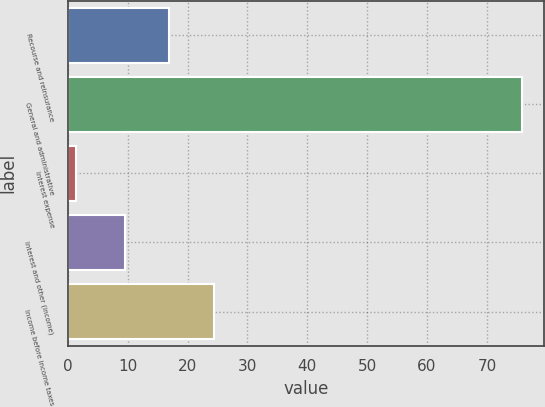Convert chart. <chart><loc_0><loc_0><loc_500><loc_500><bar_chart><fcel>Recourse and reinsurance<fcel>General and administrative<fcel>Interest expense<fcel>Interest and other (income)<fcel>Income before income taxes<nl><fcel>16.94<fcel>75.8<fcel>1.4<fcel>9.5<fcel>24.38<nl></chart> 